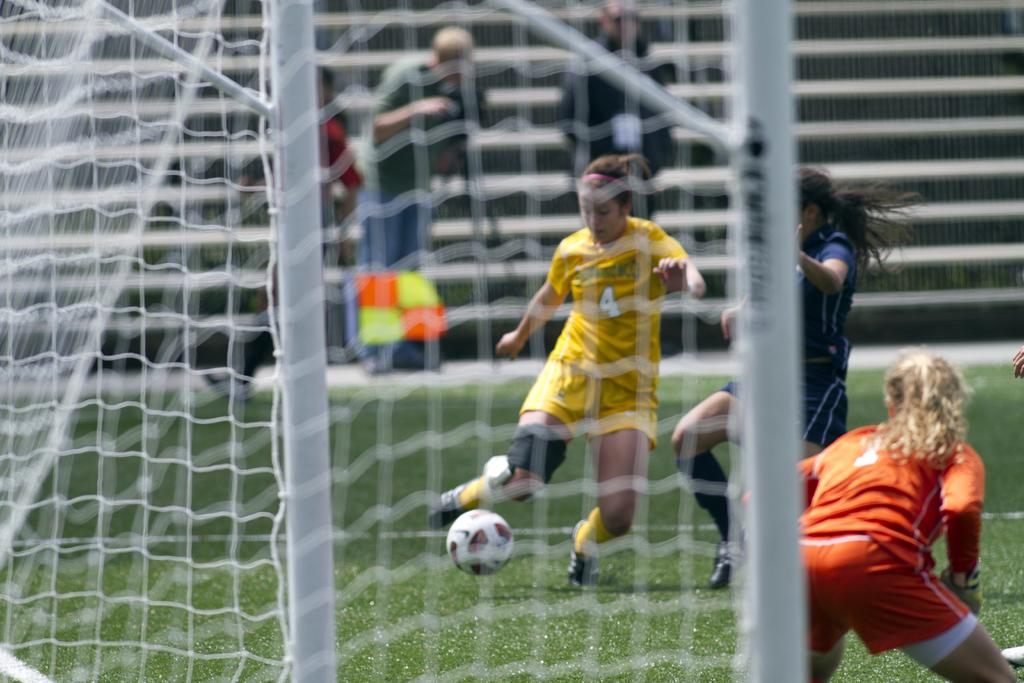What are the women in the image doing? The women in the image are playing in a playground. What object can be seen in the image that is commonly used in playground games? There is a ball in the image. What are the people on the stairs doing? There are persons standing and sitting on the stairs. What type of barrier is present in the image? There is a white-colored net in the image. How does the truck help the women play in the image? There is no truck present in the image, so it cannot help the women play. 